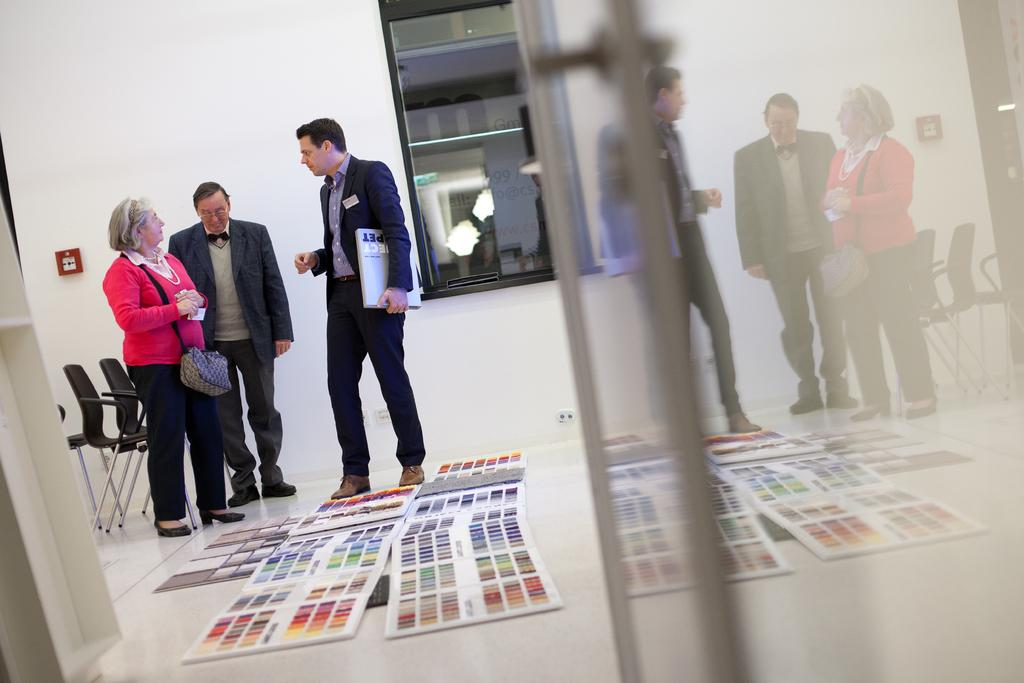What is happening in the image? There are people standing in the image. Can you describe what one of the people is holding? A man is holding a book in his hand. What can be seen in the background of the image? There are chairs in the background of the image. What objects are on the floor in the image? There are color palettes on the floor in the image. What type of tooth is visible in the image? There is no tooth visible in the image. Can you describe the dog in the image? There is no dog present in the image. 